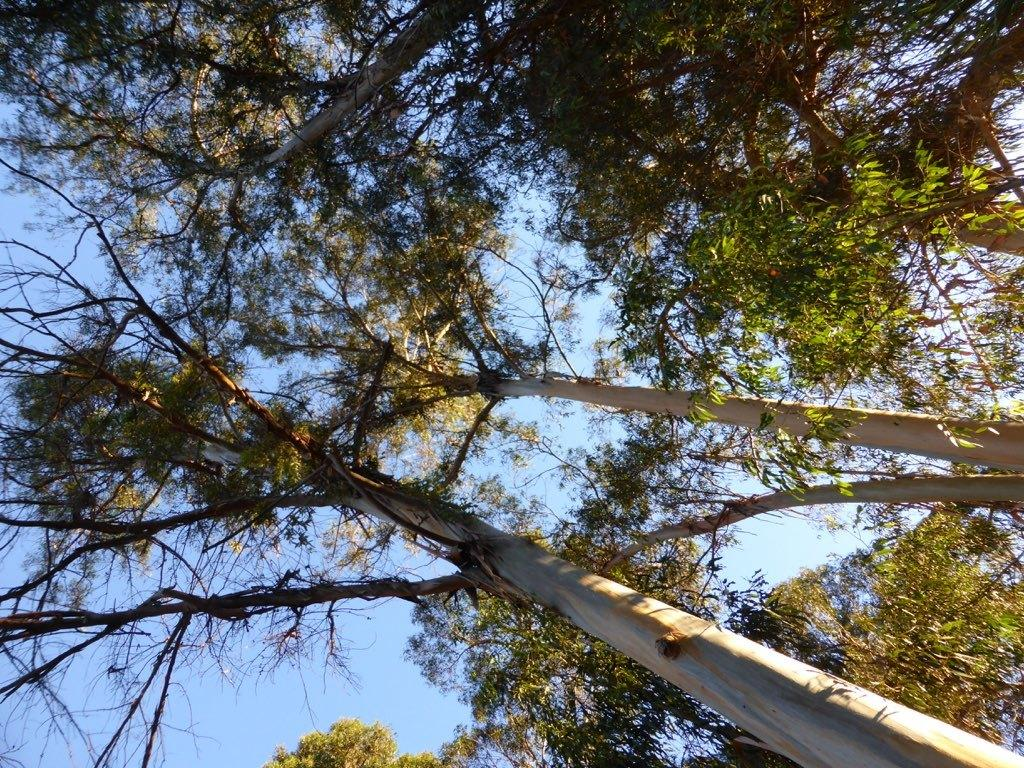What type of vegetation can be seen in the image? There are trees in the image. What part of the natural environment is visible in the image? The sky is visible in the background of the image. Where is the group playing volleyball in the image? There is no group playing volleyball present in the image. What type of mailbox can be seen in the image? There is no mailbox present in the image. 